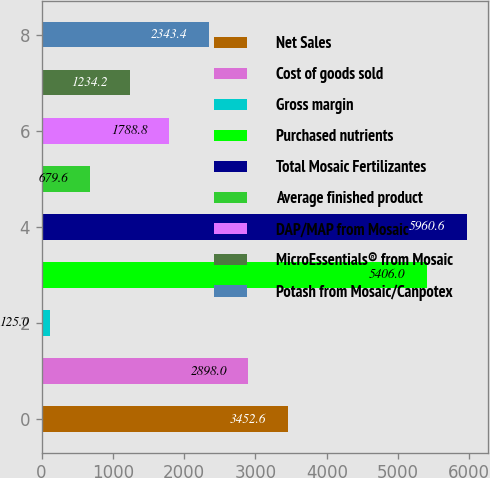<chart> <loc_0><loc_0><loc_500><loc_500><bar_chart><fcel>Net Sales<fcel>Cost of goods sold<fcel>Gross margin<fcel>Purchased nutrients<fcel>Total Mosaic Fertilizantes<fcel>Average finished product<fcel>DAP/MAP from Mosaic<fcel>MicroEssentials® from Mosaic<fcel>Potash from Mosaic/Canpotex<nl><fcel>3452.6<fcel>2898<fcel>125<fcel>5406<fcel>5960.6<fcel>679.6<fcel>1788.8<fcel>1234.2<fcel>2343.4<nl></chart> 